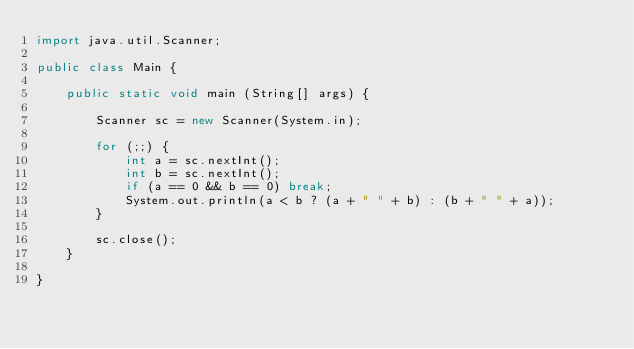<code> <loc_0><loc_0><loc_500><loc_500><_Java_>import java.util.Scanner;

public class Main {

	public static void main (String[] args) {

		Scanner sc = new Scanner(System.in);
		
		for (;;) {
			int a = sc.nextInt();
			int b = sc.nextInt();
			if (a == 0 && b == 0) break;
			System.out.println(a < b ? (a + " " + b) : (b + " " + a));
		}
		
		sc.close();
	}

}</code> 